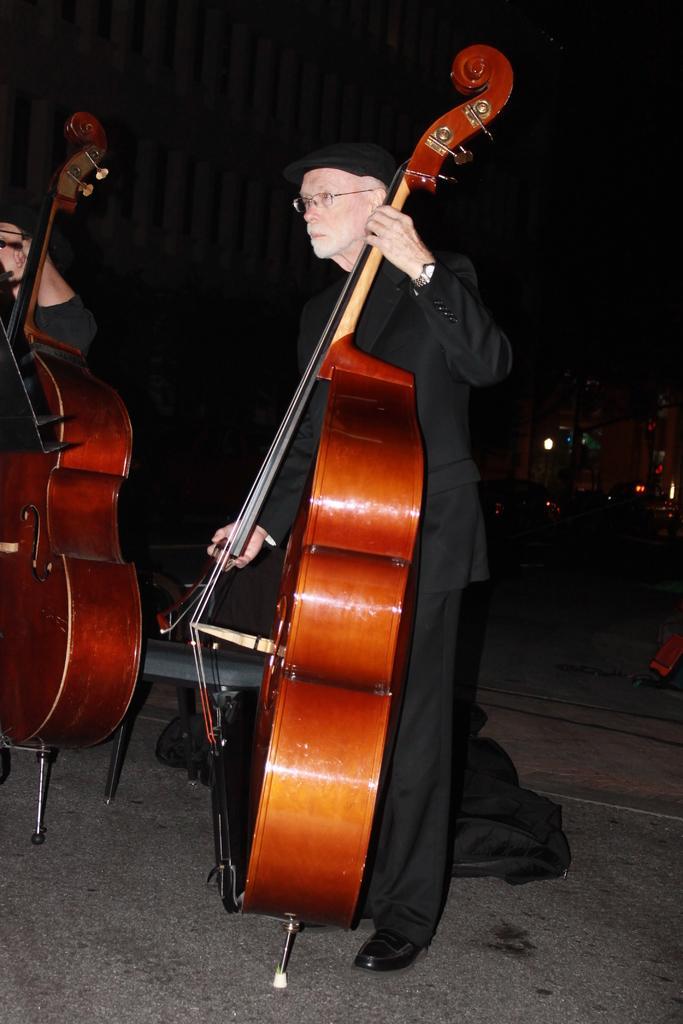Please provide a concise description of this image. In the picture there is a person wearing black dress holding a big guitar with his hand there is also another person who is holding another guitar in the background there are few lights and the road 